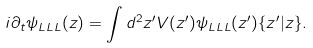Convert formula to latex. <formula><loc_0><loc_0><loc_500><loc_500>i \partial _ { t } \psi _ { L L L } ( z ) = \int d ^ { 2 } z ^ { \prime } V ( z ^ { \prime } ) \psi _ { L L L } ( z ^ { \prime } ) \{ z ^ { \prime } | z \} .</formula> 